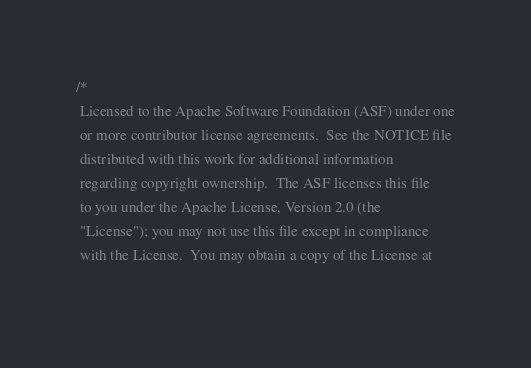<code> <loc_0><loc_0><loc_500><loc_500><_C_>/*
 Licensed to the Apache Software Foundation (ASF) under one
 or more contributor license agreements.  See the NOTICE file
 distributed with this work for additional information
 regarding copyright ownership.  The ASF licenses this file
 to you under the Apache License, Version 2.0 (the
 "License"); you may not use this file except in compliance
 with the License.  You may obtain a copy of the License at
 </code> 